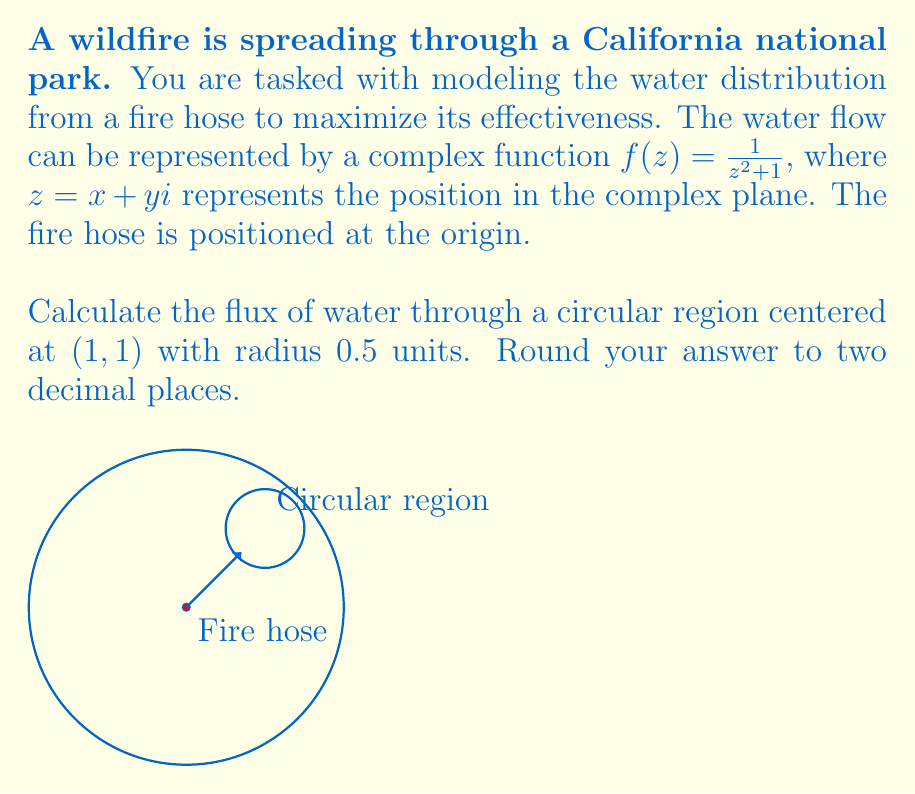Help me with this question. To solve this problem, we'll use the Residue Theorem from complex analysis. Here's the step-by-step solution:

1) The flux of water through a closed curve $C$ is given by the line integral:

   $$ \text{Flux} = \oint_C f(z) dz $$

2) By the Residue Theorem, this is equal to $2\pi i$ times the sum of the residues of $f(z)$ inside $C$.

3) First, we need to find the singularities of $f(z) = \frac{1}{z^2 + 1}$ inside the circle $(z-1-i)(z-1+i) = 0.5^2$.

4) The singularities of $f(z)$ occur at $z = \pm i$. We need to check if either of these points is inside our circle.

5) The distance from $(1,1)$ to $i$ is $\sqrt{2}$, which is greater than 0.5. So $i$ is outside our circle.

6) The distance from $(1,1)$ to $-i$ is $\sqrt{5}$, which is also greater than 0.5. So $-i$ is also outside our circle.

7) Since there are no singularities inside our circle, the residue sum is zero.

8) Therefore, the flux through the circle is zero.

9) Rounding to two decimal places, we get 0.00.
Answer: 0.00 